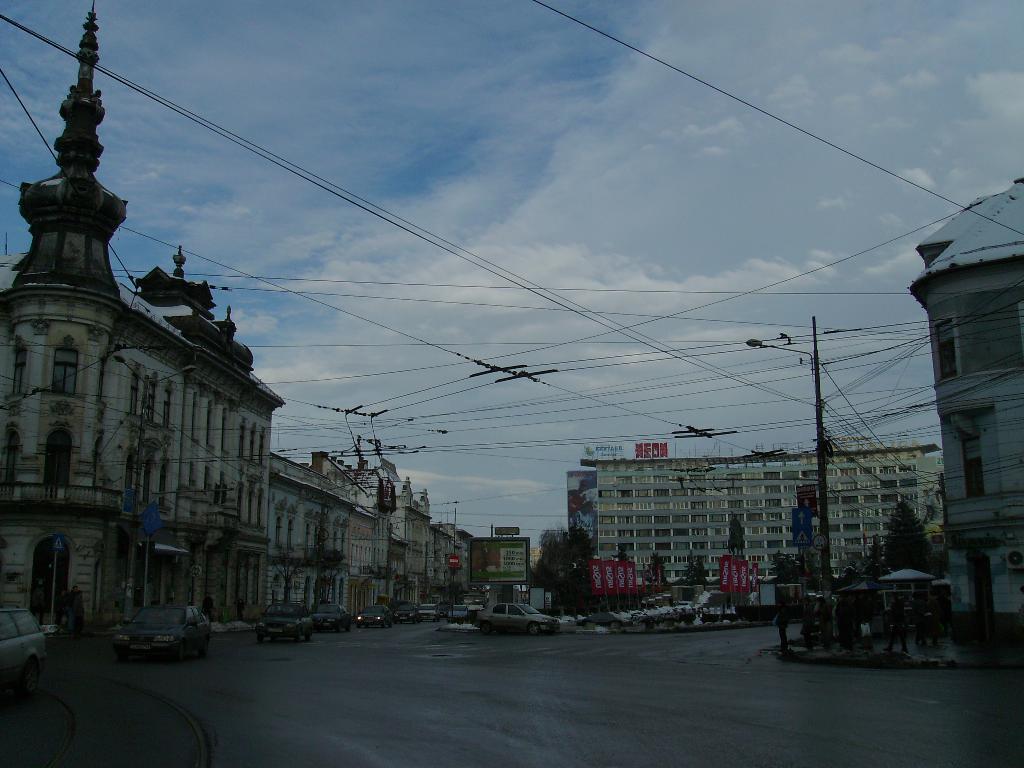Please provide a concise description of this image. In the foreground of this image, there are vehicles moving on the road. In the background, there are building, cables, poles, flags, the sky and the cloud. 